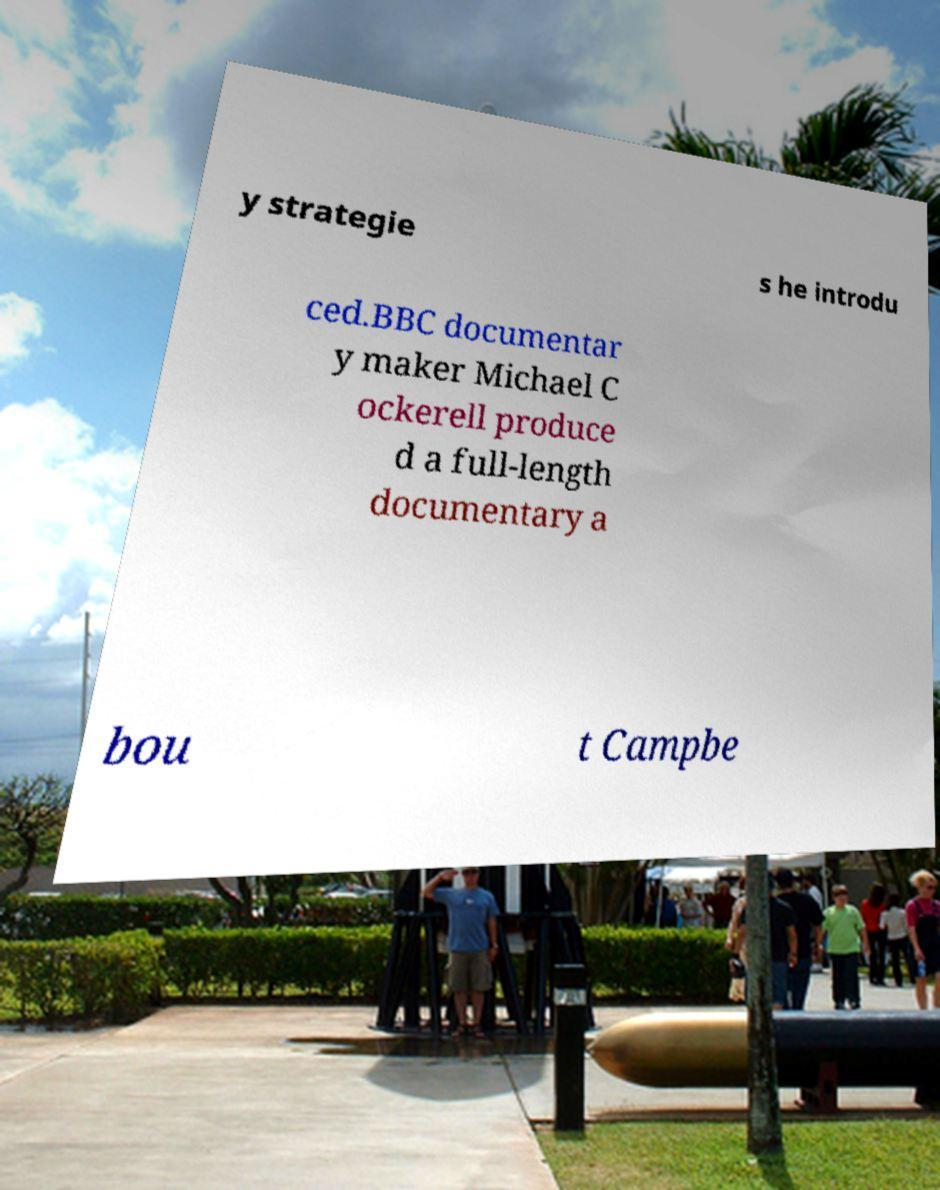What messages or text are displayed in this image? I need them in a readable, typed format. y strategie s he introdu ced.BBC documentar y maker Michael C ockerell produce d a full-length documentary a bou t Campbe 